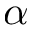<formula> <loc_0><loc_0><loc_500><loc_500>\alpha</formula> 